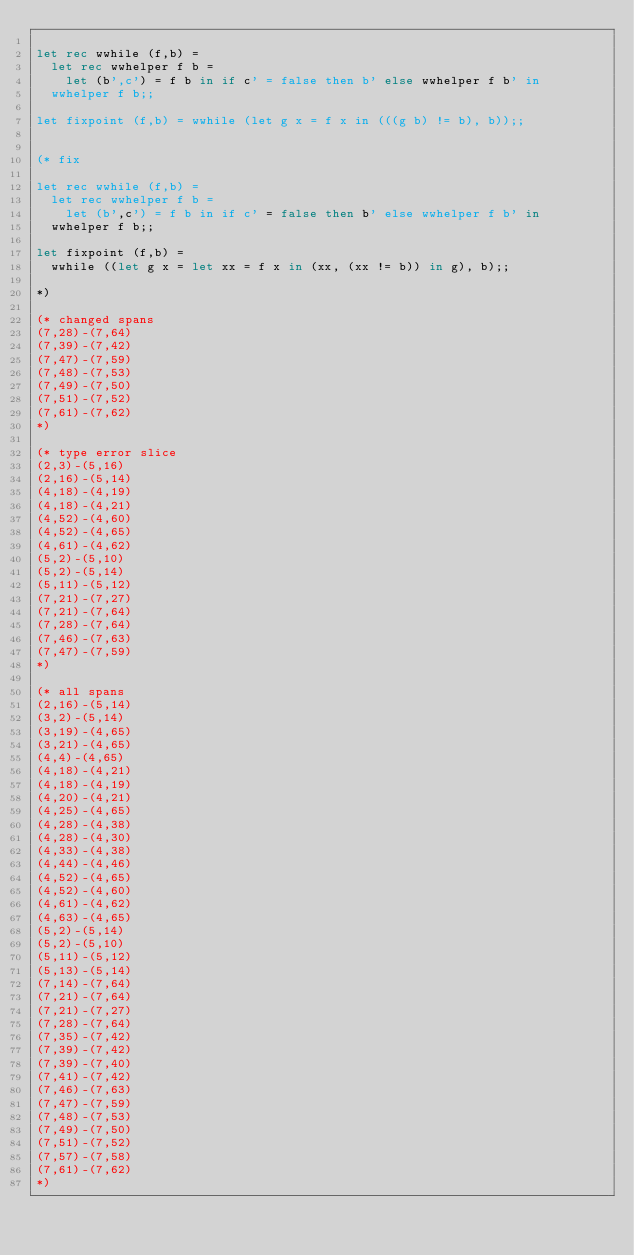<code> <loc_0><loc_0><loc_500><loc_500><_OCaml_>
let rec wwhile (f,b) =
  let rec wwhelper f b =
    let (b',c') = f b in if c' = false then b' else wwhelper f b' in
  wwhelper f b;;

let fixpoint (f,b) = wwhile (let g x = f x in (((g b) != b), b));;


(* fix

let rec wwhile (f,b) =
  let rec wwhelper f b =
    let (b',c') = f b in if c' = false then b' else wwhelper f b' in
  wwhelper f b;;

let fixpoint (f,b) =
  wwhile ((let g x = let xx = f x in (xx, (xx != b)) in g), b);;

*)

(* changed spans
(7,28)-(7,64)
(7,39)-(7,42)
(7,47)-(7,59)
(7,48)-(7,53)
(7,49)-(7,50)
(7,51)-(7,52)
(7,61)-(7,62)
*)

(* type error slice
(2,3)-(5,16)
(2,16)-(5,14)
(4,18)-(4,19)
(4,18)-(4,21)
(4,52)-(4,60)
(4,52)-(4,65)
(4,61)-(4,62)
(5,2)-(5,10)
(5,2)-(5,14)
(5,11)-(5,12)
(7,21)-(7,27)
(7,21)-(7,64)
(7,28)-(7,64)
(7,46)-(7,63)
(7,47)-(7,59)
*)

(* all spans
(2,16)-(5,14)
(3,2)-(5,14)
(3,19)-(4,65)
(3,21)-(4,65)
(4,4)-(4,65)
(4,18)-(4,21)
(4,18)-(4,19)
(4,20)-(4,21)
(4,25)-(4,65)
(4,28)-(4,38)
(4,28)-(4,30)
(4,33)-(4,38)
(4,44)-(4,46)
(4,52)-(4,65)
(4,52)-(4,60)
(4,61)-(4,62)
(4,63)-(4,65)
(5,2)-(5,14)
(5,2)-(5,10)
(5,11)-(5,12)
(5,13)-(5,14)
(7,14)-(7,64)
(7,21)-(7,64)
(7,21)-(7,27)
(7,28)-(7,64)
(7,35)-(7,42)
(7,39)-(7,42)
(7,39)-(7,40)
(7,41)-(7,42)
(7,46)-(7,63)
(7,47)-(7,59)
(7,48)-(7,53)
(7,49)-(7,50)
(7,51)-(7,52)
(7,57)-(7,58)
(7,61)-(7,62)
*)
</code> 